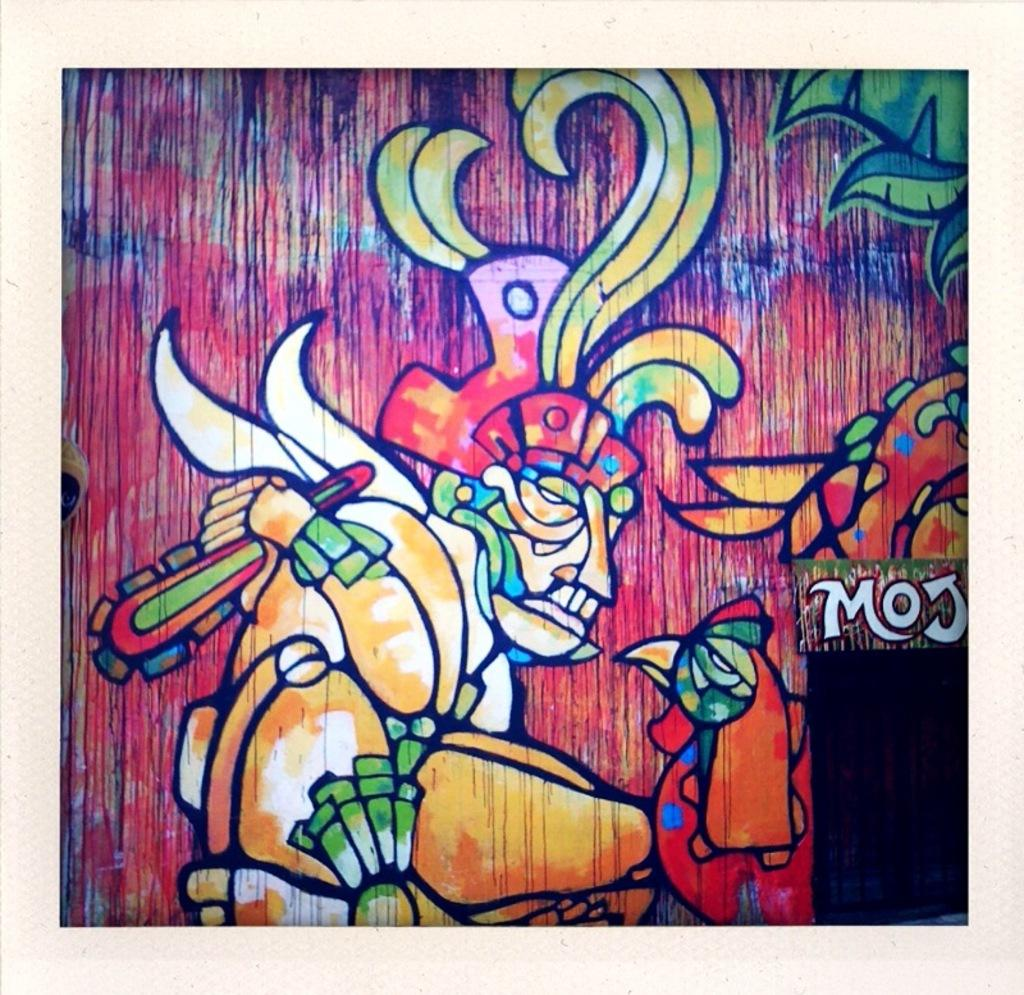<image>
Relay a brief, clear account of the picture shown. A colorful painting that includes a person with a headpiece on and the letters MOJ 